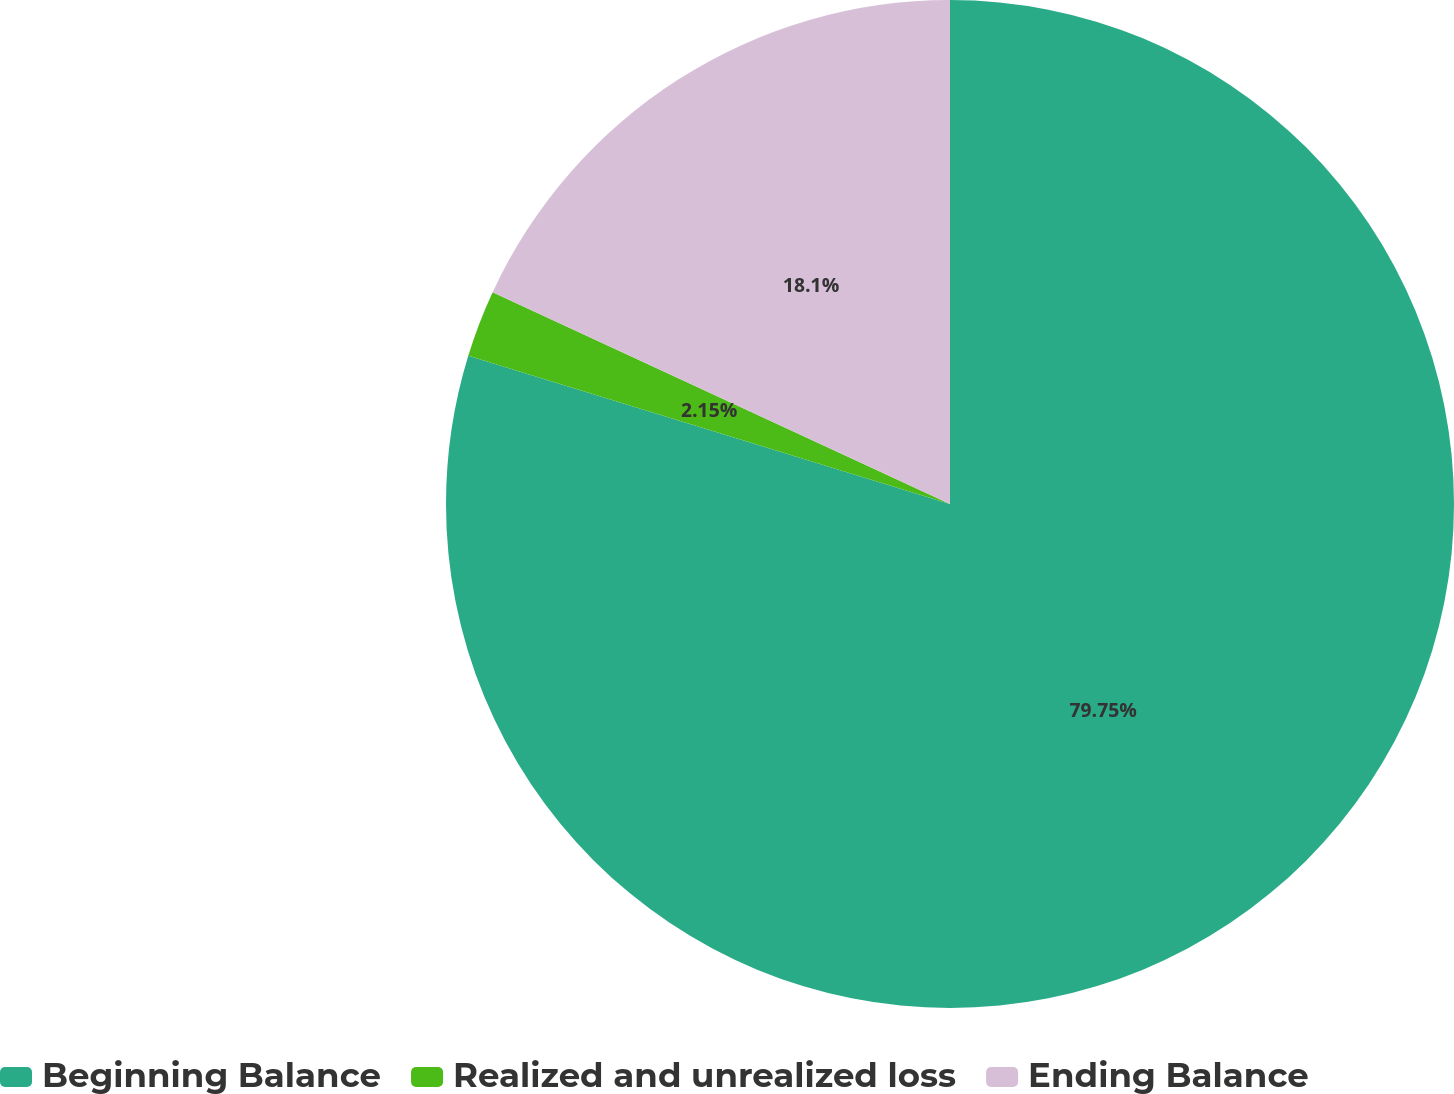Convert chart to OTSL. <chart><loc_0><loc_0><loc_500><loc_500><pie_chart><fcel>Beginning Balance<fcel>Realized and unrealized loss<fcel>Ending Balance<nl><fcel>79.75%<fcel>2.15%<fcel>18.1%<nl></chart> 